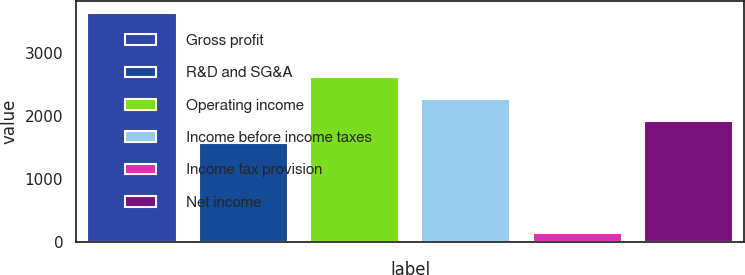<chart> <loc_0><loc_0><loc_500><loc_500><bar_chart><fcel>Gross profit<fcel>R&D and SG&A<fcel>Operating income<fcel>Income before income taxes<fcel>Income tax provision<fcel>Net income<nl><fcel>3638<fcel>1573<fcel>2620.9<fcel>2271.6<fcel>145<fcel>1922.3<nl></chart> 